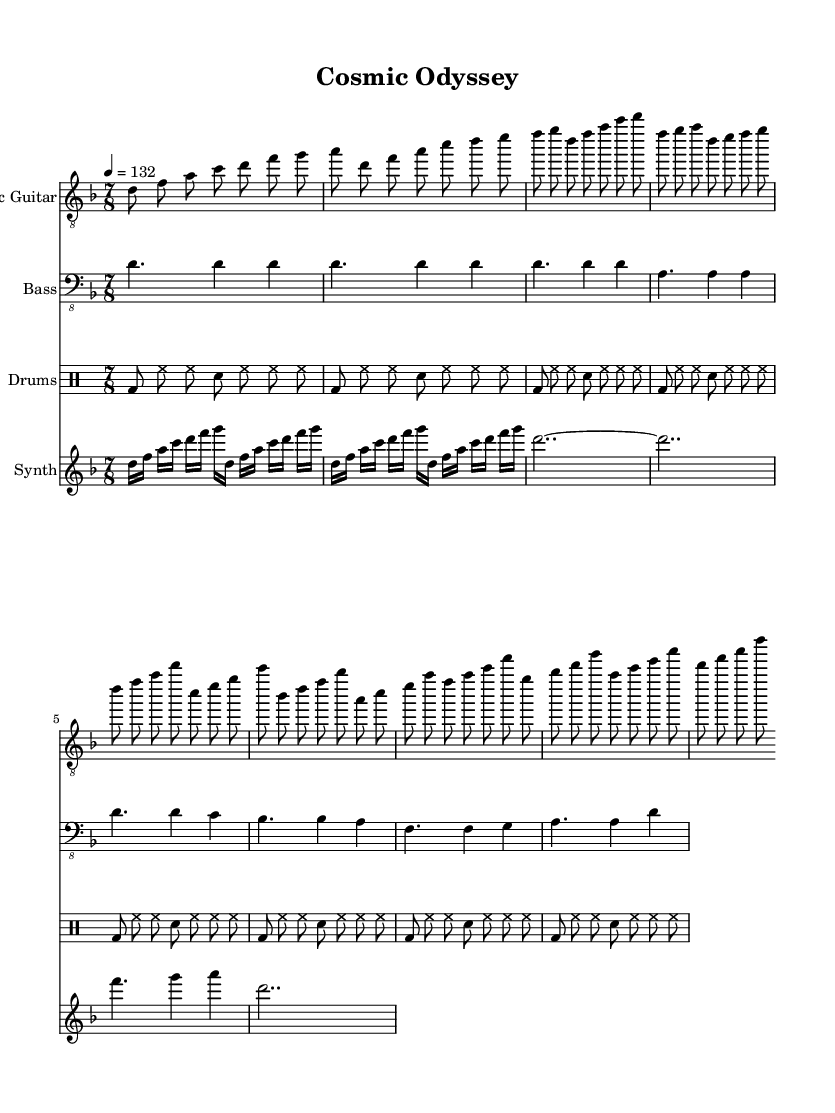What is the key signature of this music? The key signature is D minor, as indicated by the one flat in the key signature section at the beginning of the sheet music.
Answer: D minor What is the time signature of the piece? The time signature is 7/8, which is denoted at the beginning of the music; this indicates there are seven beats in each measure and the eighth note receives one count.
Answer: 7/8 What is the tempo marking for this piece? The tempo marking indicates a speed of 132 beats per minute, shown at the beginning of the sheet music. This specifies the pace at which the piece should be played.
Answer: 132 How many measures are there in the intro section? The intro section consists of four measures, counted by analyzing the music notation before the verse starts. Each measure contains a grouping of notes, which can be identified clearly by their positioning on the staff.
Answer: 4 What type of drum pattern is indicated in the sheet music? The drum part has a basic pattern consisting of bass drum, hi-hat, and snare hits. This is characterized by the alternating bass (bd) and snare (sn) placements along with constant hi-hat hits (hh), creating a standard rhythmic feel typical in metal music.
Answer: Basic pattern What is the relationship between the electric guitar and synthesizer sections? The electric guitar plays melodic lines while the synthesizer provides background textures and arpeggios. This relationship adds depth to the music, with the guitar often leading the melody, while the synthesizer supports it with ambient sounds, which is a common approach in progressive metal.
Answer: Complementary What is a unique feature of the synthesis during the intro? The unique feature is a spacey arpeggio, indicated by the repeated rapid ascending and descending notes which create an ethereal sound effect, characteristic of psychedelic elements within this metal context.
Answer: Spacey arpeggio 